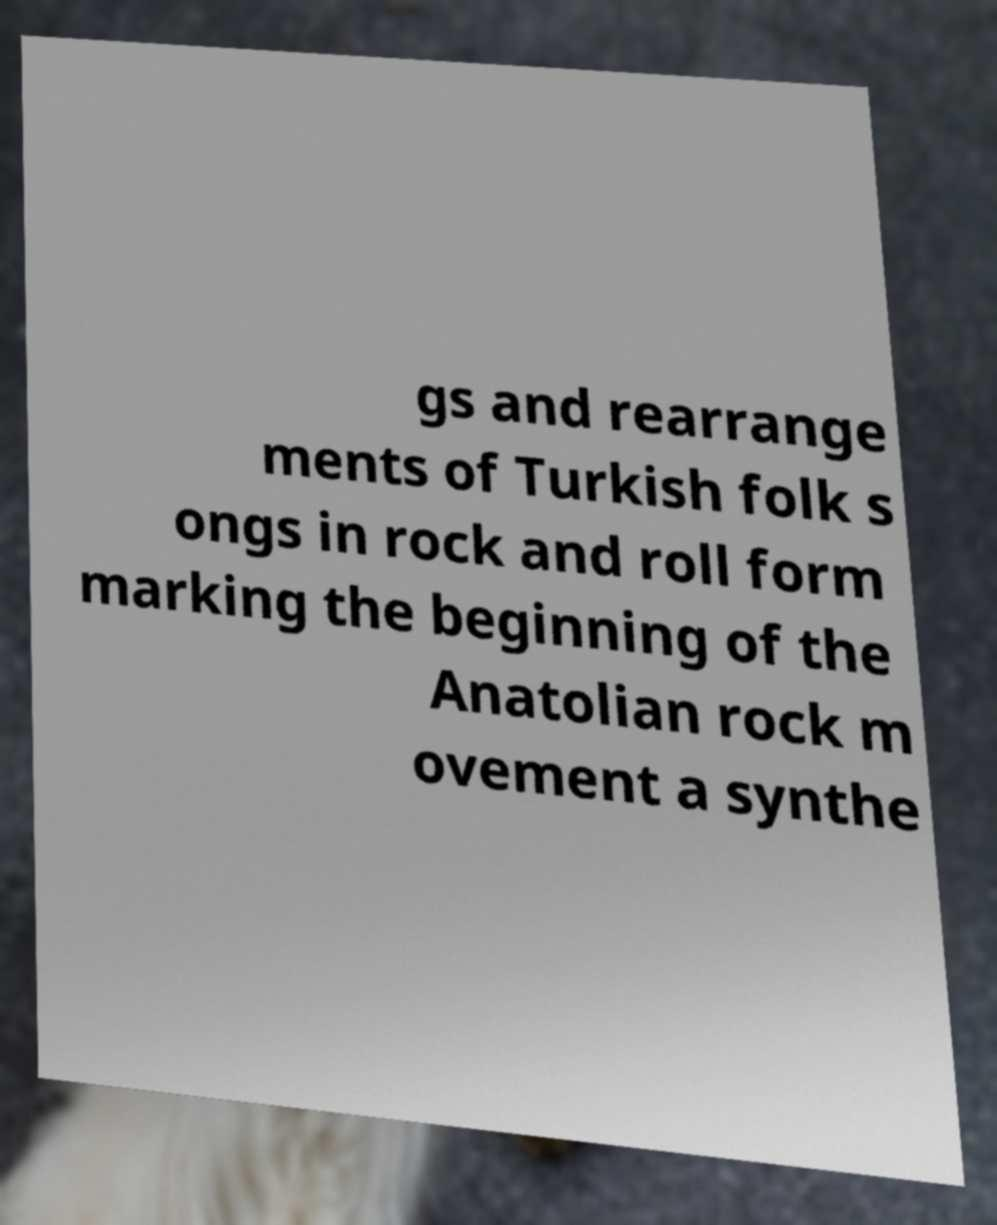There's text embedded in this image that I need extracted. Can you transcribe it verbatim? gs and rearrange ments of Turkish folk s ongs in rock and roll form marking the beginning of the Anatolian rock m ovement a synthe 